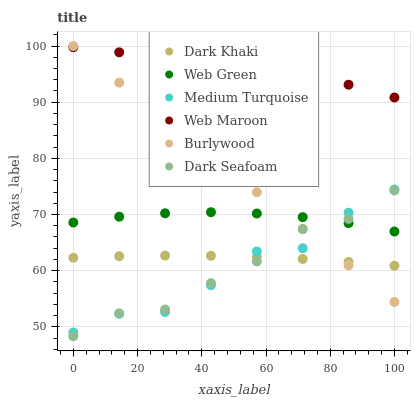Does Medium Turquoise have the minimum area under the curve?
Answer yes or no. Yes. Does Web Maroon have the maximum area under the curve?
Answer yes or no. Yes. Does Web Green have the minimum area under the curve?
Answer yes or no. No. Does Web Green have the maximum area under the curve?
Answer yes or no. No. Is Burlywood the smoothest?
Answer yes or no. Yes. Is Medium Turquoise the roughest?
Answer yes or no. Yes. Is Web Maroon the smoothest?
Answer yes or no. No. Is Web Maroon the roughest?
Answer yes or no. No. Does Dark Seafoam have the lowest value?
Answer yes or no. Yes. Does Web Green have the lowest value?
Answer yes or no. No. Does Burlywood have the highest value?
Answer yes or no. Yes. Does Web Maroon have the highest value?
Answer yes or no. No. Is Dark Seafoam less than Web Maroon?
Answer yes or no. Yes. Is Web Maroon greater than Dark Seafoam?
Answer yes or no. Yes. Does Dark Seafoam intersect Web Green?
Answer yes or no. Yes. Is Dark Seafoam less than Web Green?
Answer yes or no. No. Is Dark Seafoam greater than Web Green?
Answer yes or no. No. Does Dark Seafoam intersect Web Maroon?
Answer yes or no. No. 